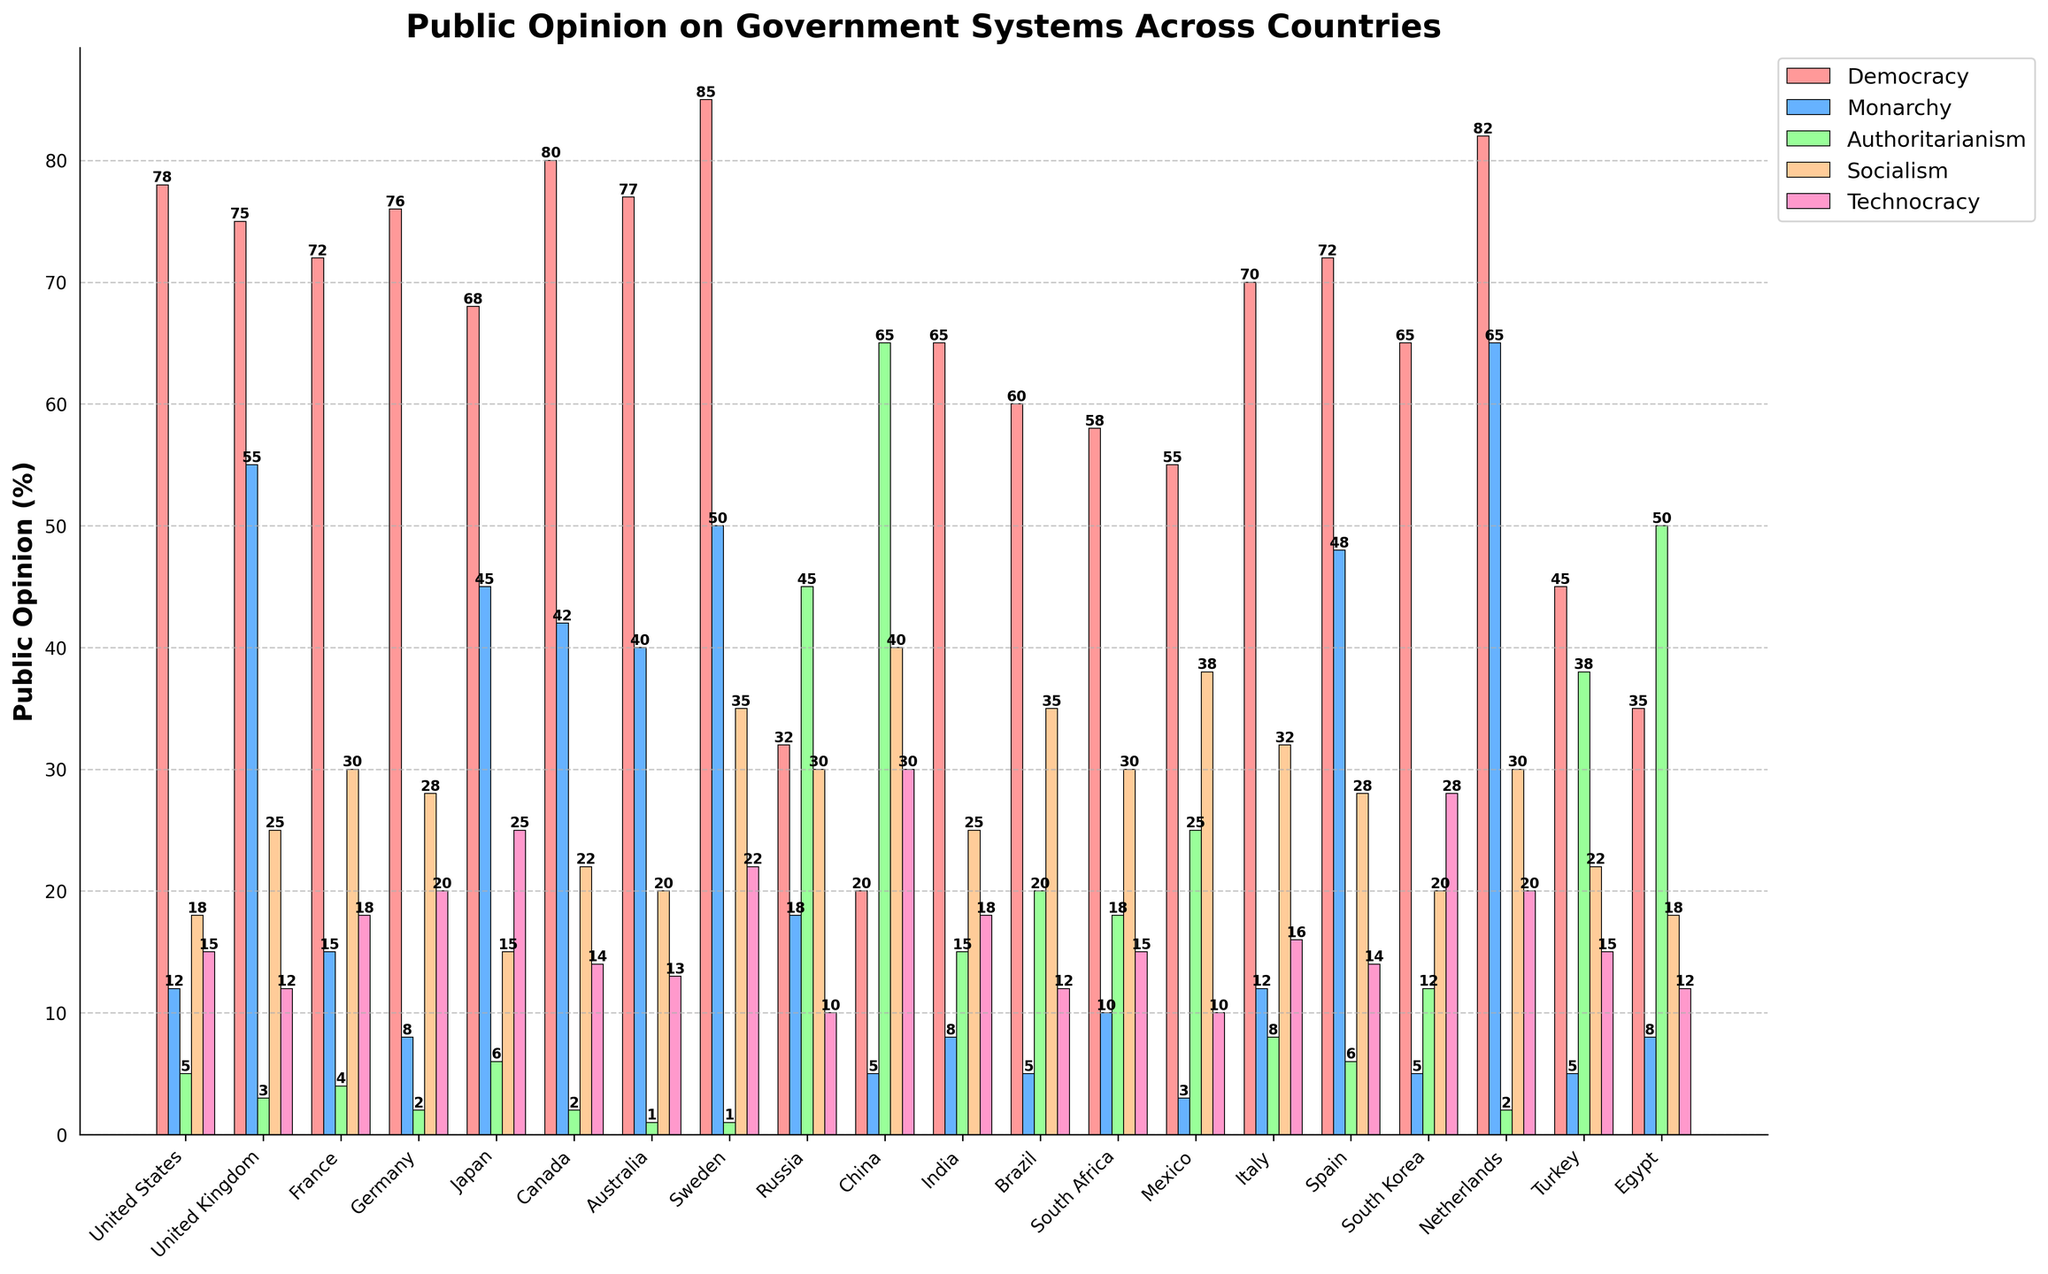Which country has the highest public opinion for democracy? The bar chart shows public opinion percentages for various government systems. Looking at the bars for democracy, Sweden has the highest value.
Answer: Sweden Which country has the least support for monarchy? By comparing the heights of the bars representing monarchy, Mexico has the lowest value.
Answer: Mexico What's the sum of public opinion percentages for technocracy in France, Japan, and Egypt? Adding the values for technocracy in these countries: France (18) + Japan (25) + Egypt (12) equals 55.
Answer: 55 Compare the support for socialism between China and Brazil. Which has higher support and by how much? The bar for socialism in China (40) is taller than in Brazil (35). The difference is 40 - 35, so China has 5% more support for socialism than Brazil.
Answer: China, by 5% Which country has the highest support for authoritarianism, and what is the percentage? Among the authoritarianism bars, China has the highest with 65%.
Answer: China, 65% Is the opinion for democracy in Germany greater than the opinion for socialism in the same country? By how much? The chart shows 76% for democracy and 28% for socialism in Germany. The difference is 76 - 28, making democracy 48% more popular than socialism.
Answer: Yes, by 48% What's the average public opinion percentage for authoritarianism across all countries? Sum the percentages for authoritarianism and divide by the number of countries: (5+3+4+2+6+2+1+1+45+65+15+20+18+25+8+6+12+2+38+50) / 20 = 13.2%
Answer: 13.2% Which country has the closest public opinion percentages between democracy and technocracy? Reviewing the bars for both systems, Japan has democracy at 68% and technocracy at 25%, with a smaller difference of 43%.
Answer: Japan Does the support for monarchy in the United States differ significantly from that in Russia? The bar for monarchy in the US is 12%, while in Russia it is 18%. The difference is 18 - 12, which is 6%.
Answer: Yes, by 6% What is the combined support percentage for democracy and monarchy in Canada? Adding the values for democracy (80) and monarchy (42) in Canada, we get 80 + 42 = 122.
Answer: 122 